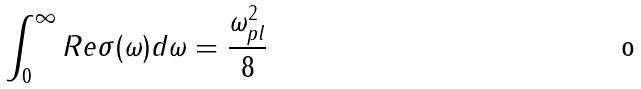Convert formula to latex. <formula><loc_0><loc_0><loc_500><loc_500>\int _ { 0 } ^ { \infty } R e \sigma ( { \omega } ) d \omega = \frac { \omega _ { p l } ^ { 2 } } { 8 }</formula> 